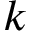Convert formula to latex. <formula><loc_0><loc_0><loc_500><loc_500>k</formula> 